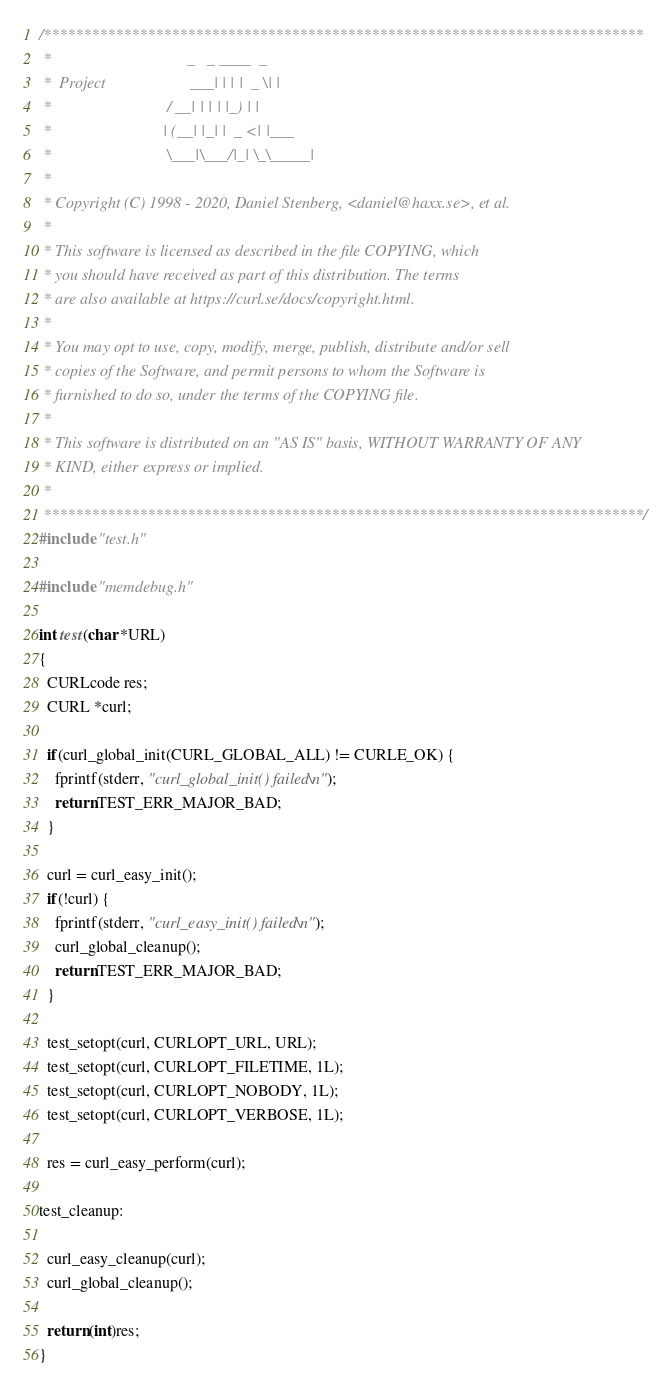Convert code to text. <code><loc_0><loc_0><loc_500><loc_500><_C_>/***************************************************************************
 *                                  _   _ ____  _
 *  Project                     ___| | | |  _ \| |
 *                             / __| | | | |_) | |
 *                            | (__| |_| |  _ <| |___
 *                             \___|\___/|_| \_\_____|
 *
 * Copyright (C) 1998 - 2020, Daniel Stenberg, <daniel@haxx.se>, et al.
 *
 * This software is licensed as described in the file COPYING, which
 * you should have received as part of this distribution. The terms
 * are also available at https://curl.se/docs/copyright.html.
 *
 * You may opt to use, copy, modify, merge, publish, distribute and/or sell
 * copies of the Software, and permit persons to whom the Software is
 * furnished to do so, under the terms of the COPYING file.
 *
 * This software is distributed on an "AS IS" basis, WITHOUT WARRANTY OF ANY
 * KIND, either express or implied.
 *
 ***************************************************************************/
#include "test.h"

#include "memdebug.h"

int test(char *URL)
{
  CURLcode res;
  CURL *curl;

  if(curl_global_init(CURL_GLOBAL_ALL) != CURLE_OK) {
    fprintf(stderr, "curl_global_init() failed\n");
    return TEST_ERR_MAJOR_BAD;
  }

  curl = curl_easy_init();
  if(!curl) {
    fprintf(stderr, "curl_easy_init() failed\n");
    curl_global_cleanup();
    return TEST_ERR_MAJOR_BAD;
  }

  test_setopt(curl, CURLOPT_URL, URL);
  test_setopt(curl, CURLOPT_FILETIME, 1L);
  test_setopt(curl, CURLOPT_NOBODY, 1L);
  test_setopt(curl, CURLOPT_VERBOSE, 1L);

  res = curl_easy_perform(curl);

test_cleanup:

  curl_easy_cleanup(curl);
  curl_global_cleanup();

  return (int)res;
}
</code> 